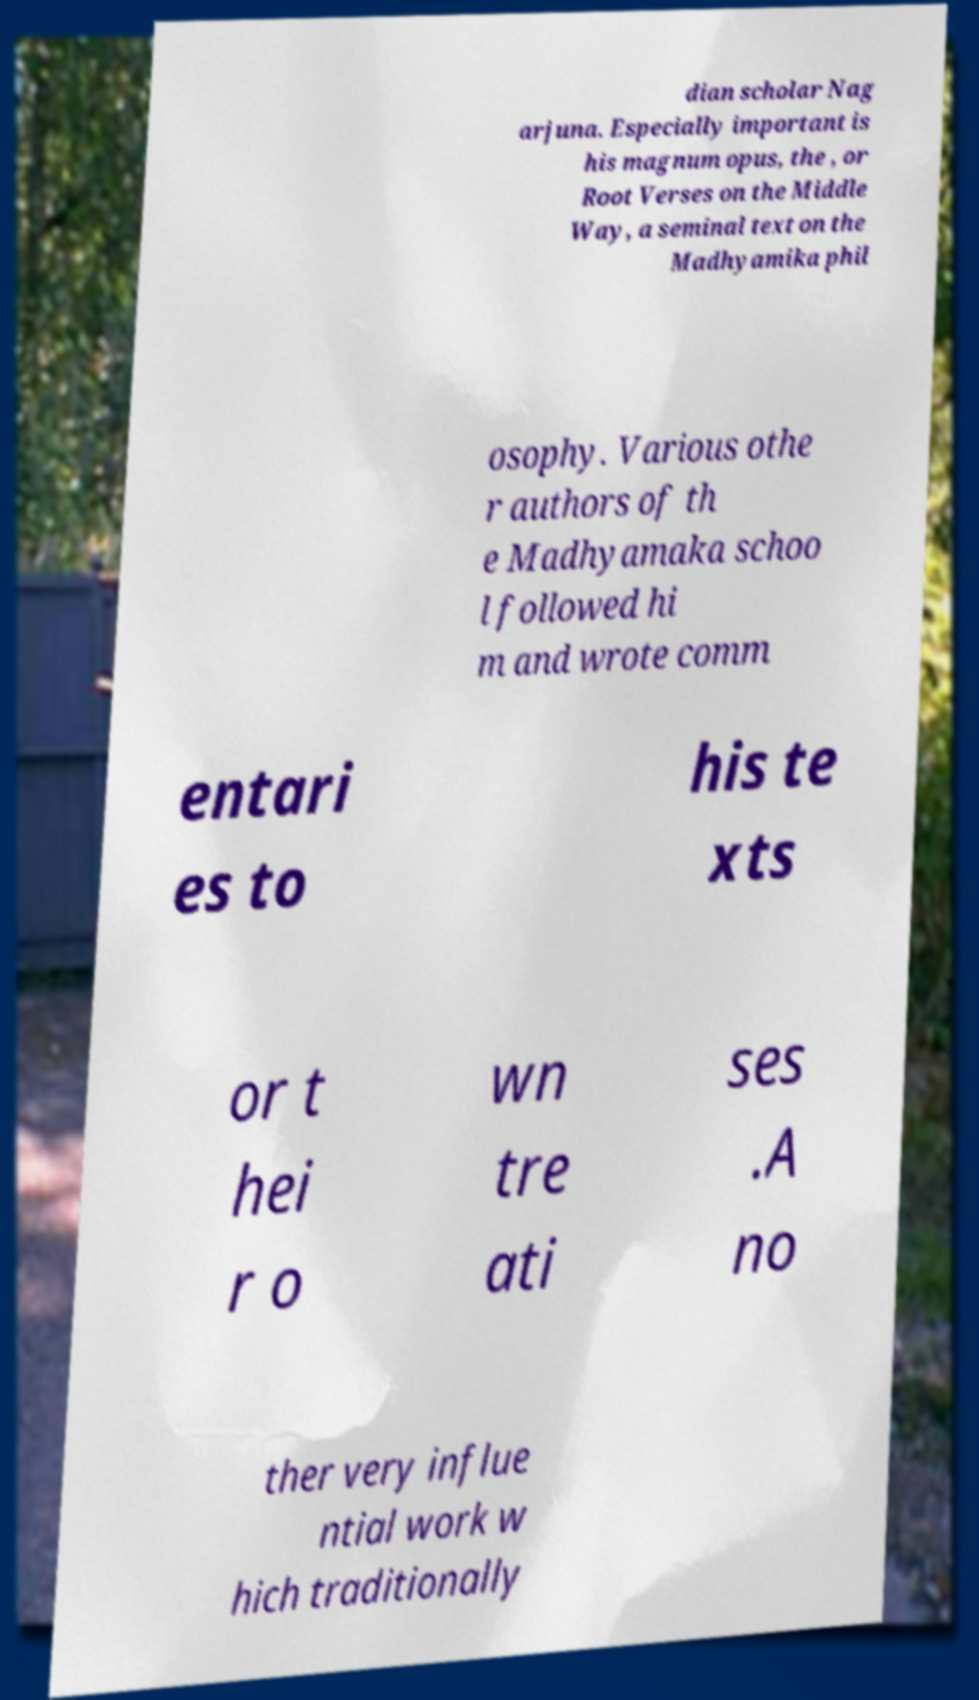For documentation purposes, I need the text within this image transcribed. Could you provide that? dian scholar Nag arjuna. Especially important is his magnum opus, the , or Root Verses on the Middle Way, a seminal text on the Madhyamika phil osophy. Various othe r authors of th e Madhyamaka schoo l followed hi m and wrote comm entari es to his te xts or t hei r o wn tre ati ses .A no ther very influe ntial work w hich traditionally 